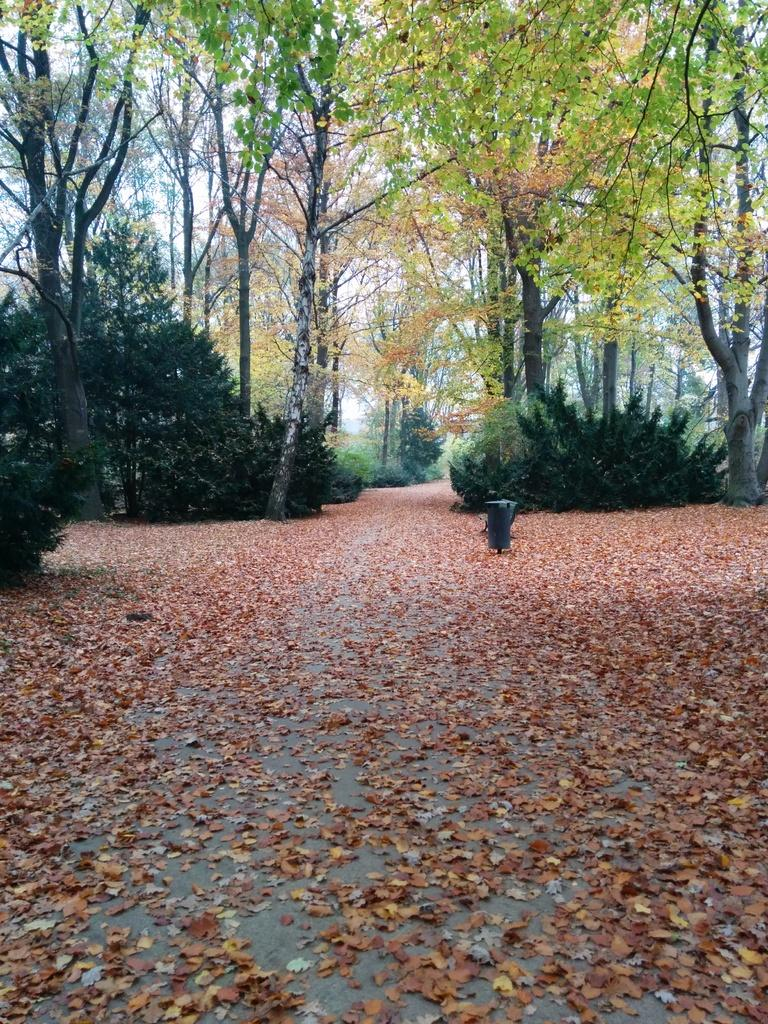What is present on the ground in the image? There are leaves on the ground in the image. What can be seen in the background of the image? There are trees visible in the background of the image. Is there a light shining on the leaves in the image? There is no mention of a light shining on the leaves in the image, so we cannot determine if there is one present. 